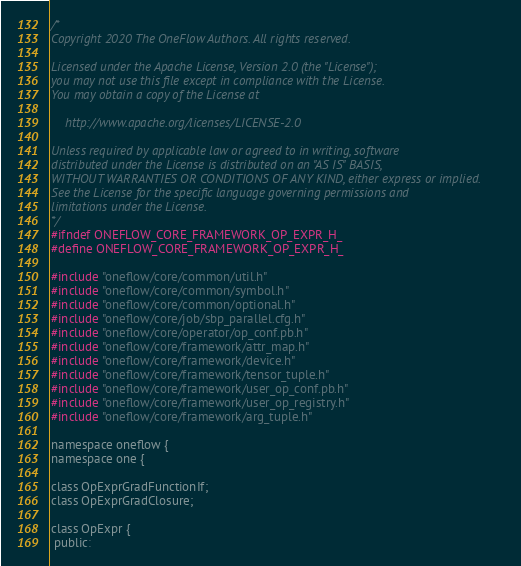<code> <loc_0><loc_0><loc_500><loc_500><_C_>/*
Copyright 2020 The OneFlow Authors. All rights reserved.

Licensed under the Apache License, Version 2.0 (the "License");
you may not use this file except in compliance with the License.
You may obtain a copy of the License at

    http://www.apache.org/licenses/LICENSE-2.0

Unless required by applicable law or agreed to in writing, software
distributed under the License is distributed on an "AS IS" BASIS,
WITHOUT WARRANTIES OR CONDITIONS OF ANY KIND, either express or implied.
See the License for the specific language governing permissions and
limitations under the License.
*/
#ifndef ONEFLOW_CORE_FRAMEWORK_OP_EXPR_H_
#define ONEFLOW_CORE_FRAMEWORK_OP_EXPR_H_

#include "oneflow/core/common/util.h"
#include "oneflow/core/common/symbol.h"
#include "oneflow/core/common/optional.h"
#include "oneflow/core/job/sbp_parallel.cfg.h"
#include "oneflow/core/operator/op_conf.pb.h"
#include "oneflow/core/framework/attr_map.h"
#include "oneflow/core/framework/device.h"
#include "oneflow/core/framework/tensor_tuple.h"
#include "oneflow/core/framework/user_op_conf.pb.h"
#include "oneflow/core/framework/user_op_registry.h"
#include "oneflow/core/framework/arg_tuple.h"

namespace oneflow {
namespace one {

class OpExprGradFunctionIf;
class OpExprGradClosure;

class OpExpr {
 public:</code> 